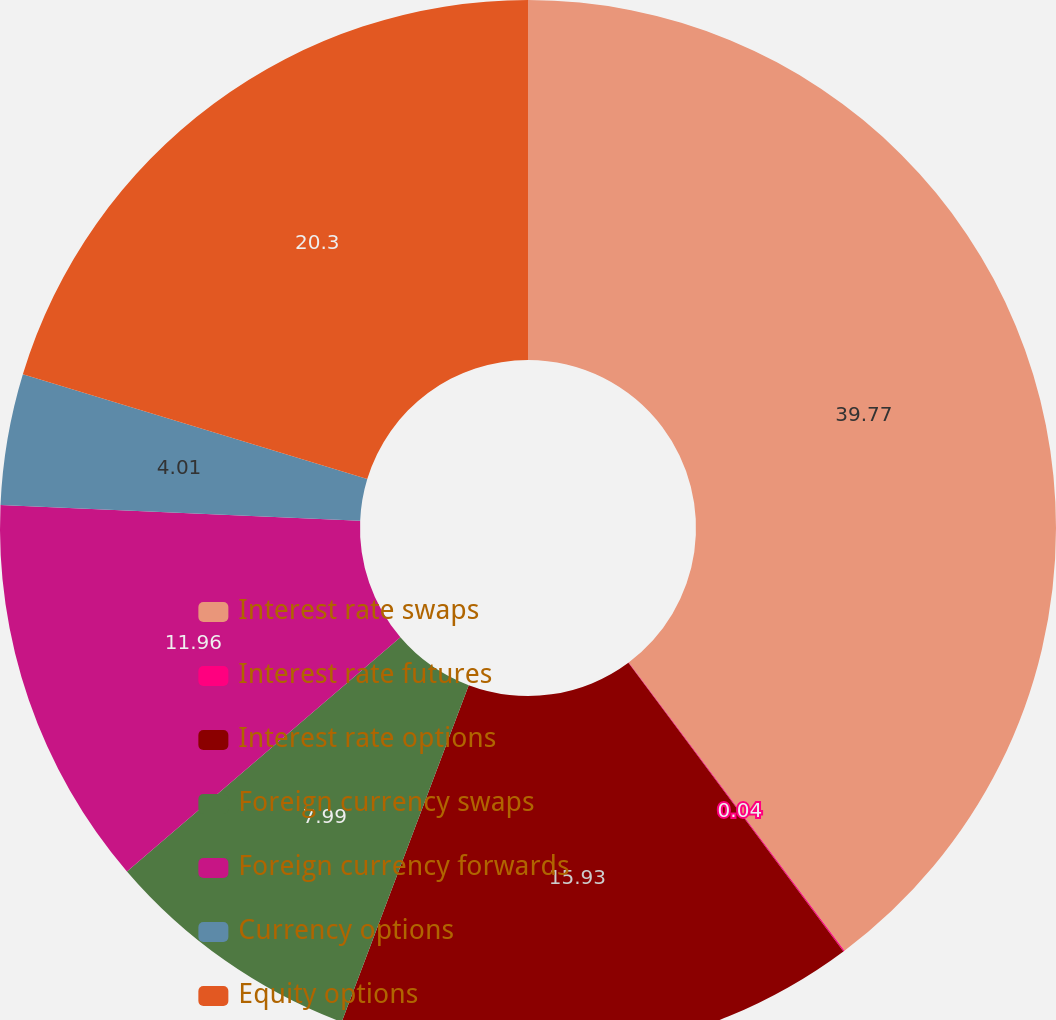<chart> <loc_0><loc_0><loc_500><loc_500><pie_chart><fcel>Interest rate swaps<fcel>Interest rate futures<fcel>Interest rate options<fcel>Foreign currency swaps<fcel>Foreign currency forwards<fcel>Currency options<fcel>Equity options<nl><fcel>39.77%<fcel>0.04%<fcel>15.93%<fcel>7.99%<fcel>11.96%<fcel>4.01%<fcel>20.3%<nl></chart> 